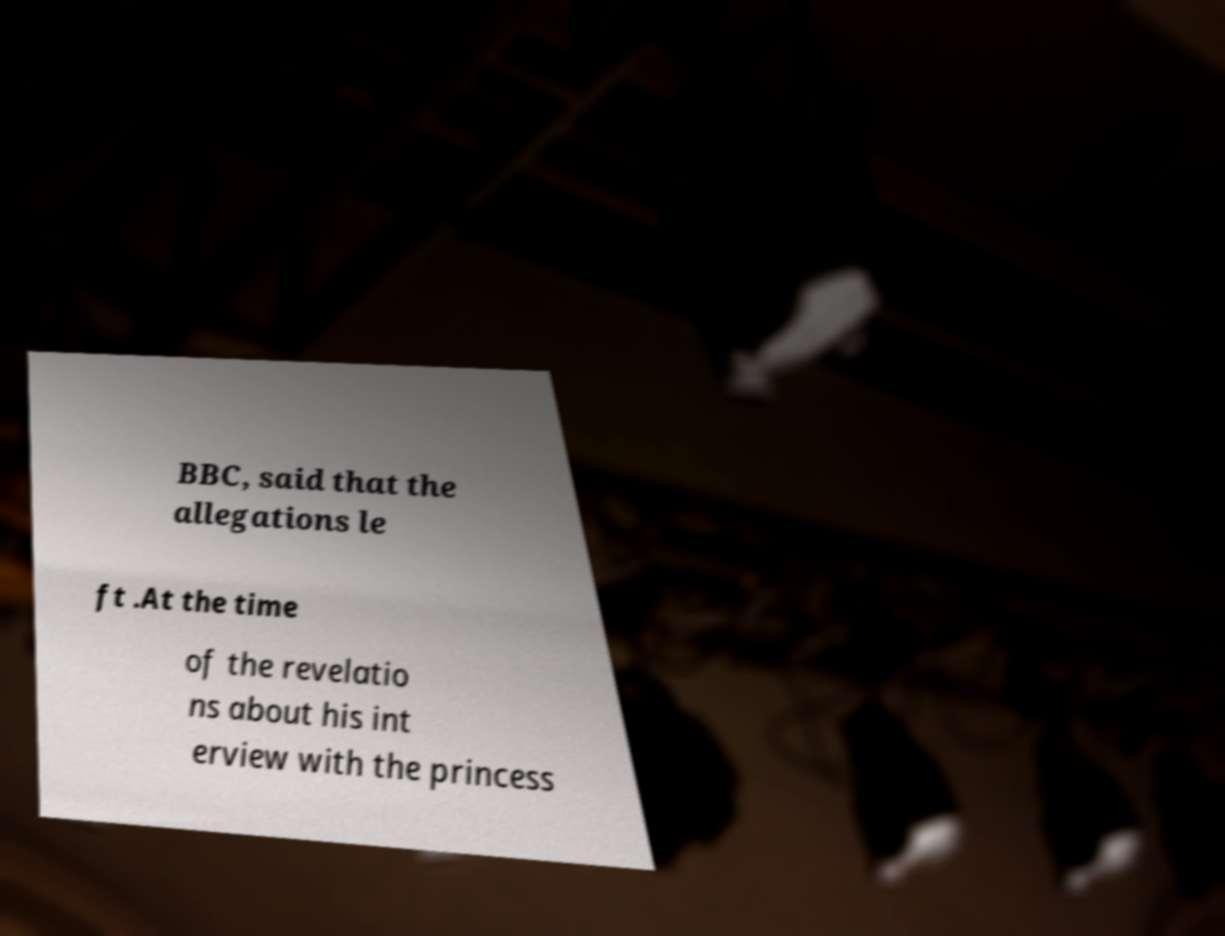For documentation purposes, I need the text within this image transcribed. Could you provide that? BBC, said that the allegations le ft .At the time of the revelatio ns about his int erview with the princess 